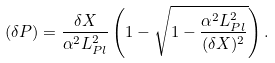Convert formula to latex. <formula><loc_0><loc_0><loc_500><loc_500>( \delta P ) = \frac { \delta X } { \alpha ^ { 2 } L _ { P l } ^ { 2 } } \left ( 1 - \sqrt { 1 - \frac { \alpha ^ { 2 } L _ { P l } ^ { 2 } } { ( \delta X ) ^ { 2 } } } \right ) .</formula> 